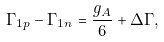Convert formula to latex. <formula><loc_0><loc_0><loc_500><loc_500>\Gamma _ { 1 p } - \Gamma _ { 1 n } = \frac { g _ { A } } { 6 } + \Delta \Gamma ,</formula> 